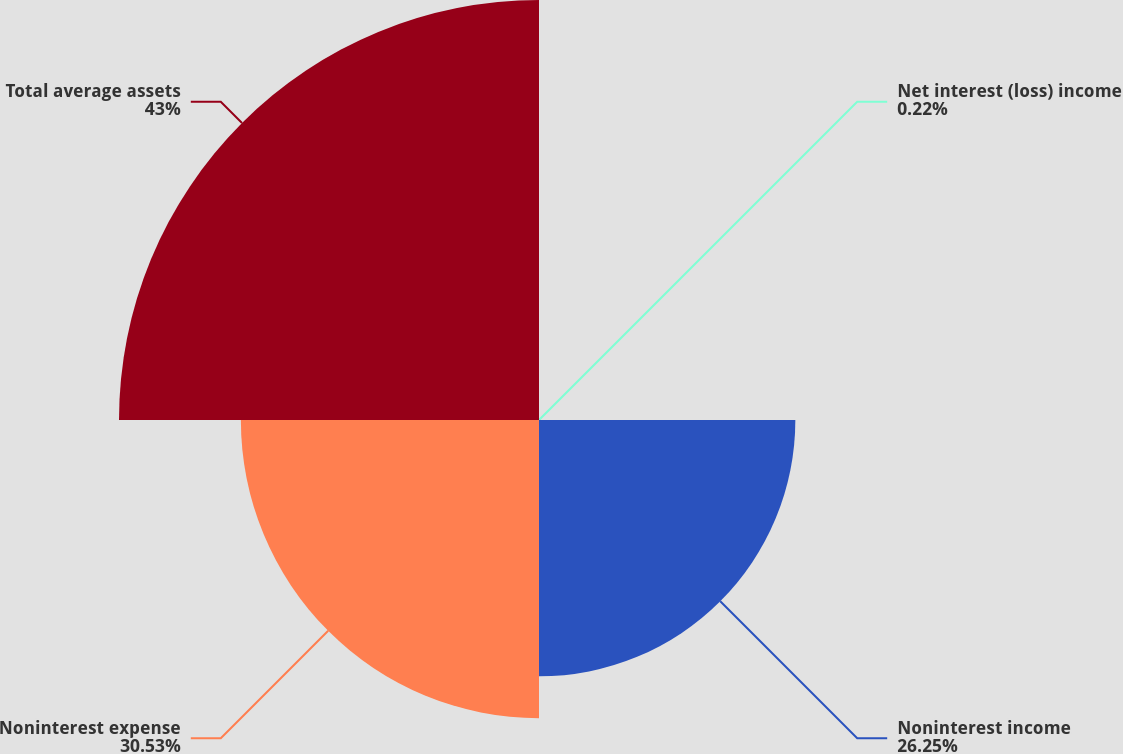Convert chart to OTSL. <chart><loc_0><loc_0><loc_500><loc_500><pie_chart><fcel>Net interest (loss) income<fcel>Noninterest income<fcel>Noninterest expense<fcel>Total average assets<nl><fcel>0.22%<fcel>26.25%<fcel>30.53%<fcel>43.01%<nl></chart> 